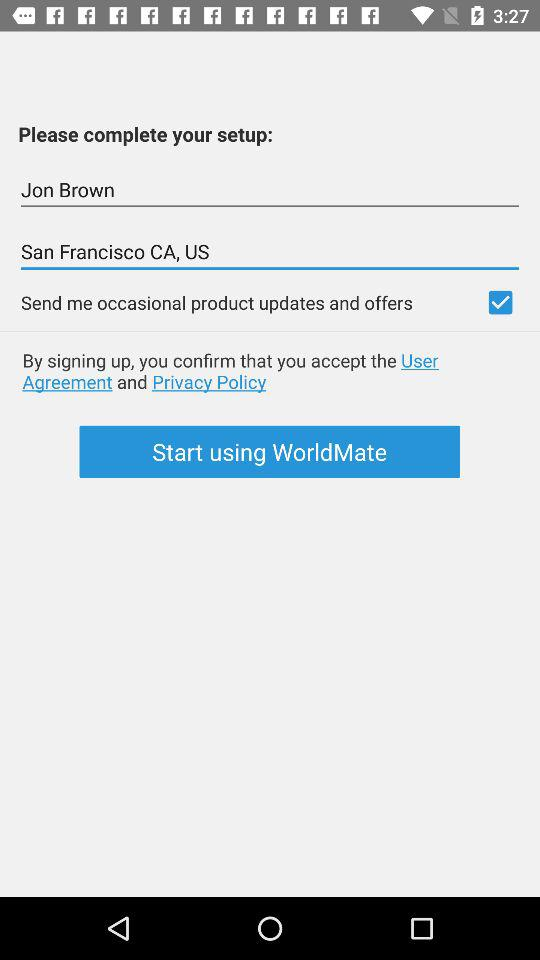What's the status for "Send me occasional product updates and offers"? The status is on. 